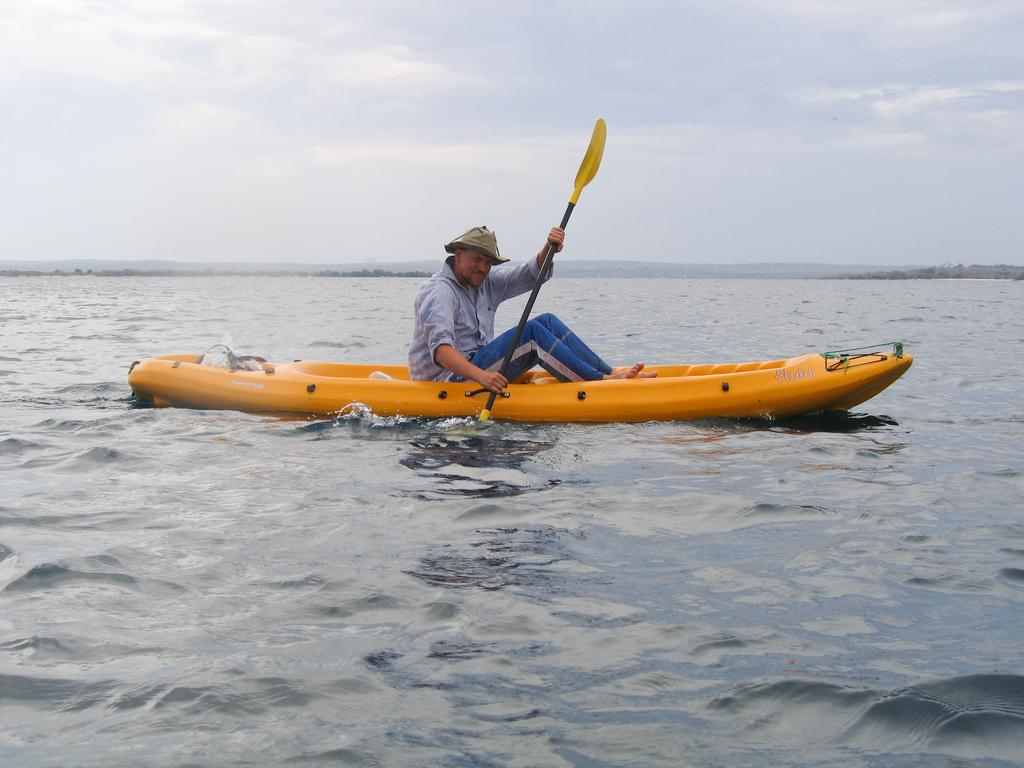What is the person in the image doing? The person is sitting in a boat. What is the person holding in the image? The person is holding a paddle. Where is the boat located in the image? The boat is on the water. How would you describe the sky in the background of the image? The sky in the background has a white and blue color. What type of ink is being used to write on the dime in the image? There is no dime or writing present in the image. How does the acoustics of the boat affect the person's experience in the image? The image does not provide information about the acoustics of the boat, so it cannot be determined how it affects the person's experience. 